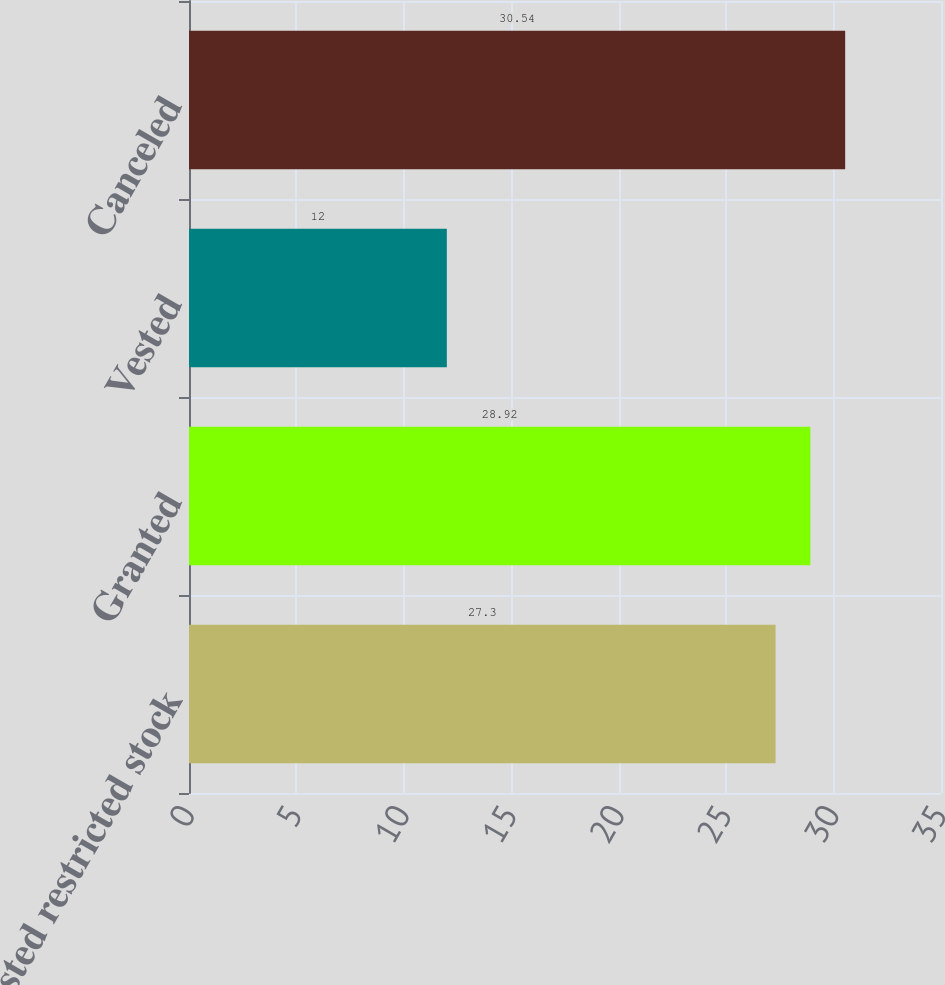Convert chart to OTSL. <chart><loc_0><loc_0><loc_500><loc_500><bar_chart><fcel>Nonvested restricted stock<fcel>Granted<fcel>Vested<fcel>Canceled<nl><fcel>27.3<fcel>28.92<fcel>12<fcel>30.54<nl></chart> 